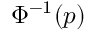Convert formula to latex. <formula><loc_0><loc_0><loc_500><loc_500>\Phi ^ { - 1 } ( p )</formula> 